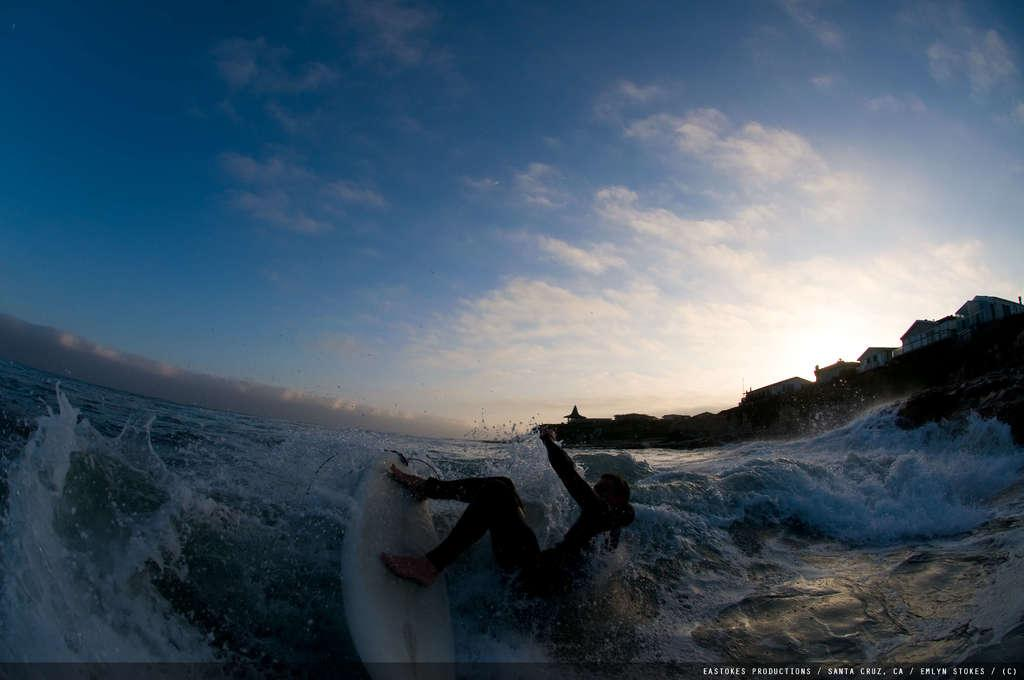Who or what is the main subject in the image? There is a person in the image. Where is the person located in the image? The person is in the center of the image. What is the person doing in the image? The person is surfing in the water. What can be seen at the bottom side of the image? There is water visible at the bottom side of the image. What type of curve can be seen in the image? There is no curve present in the image; it features a person surfing in the water. What story is being told in the image? The image does not tell a story; it simply shows a person surfing in the water. 